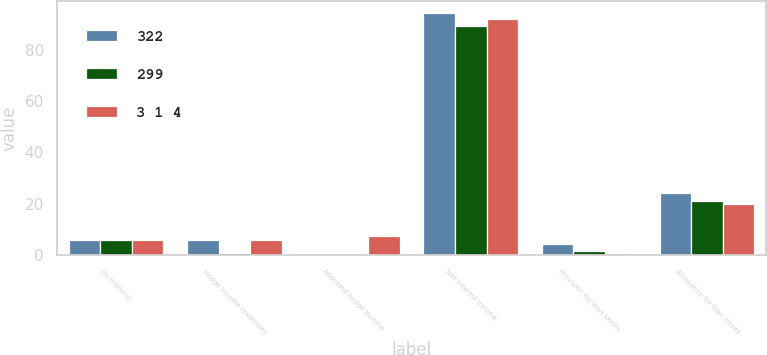<chart> <loc_0><loc_0><loc_500><loc_500><stacked_bar_chart><ecel><fcel>(In millions)<fcel>Hedge income (expense)<fcel>Allocated hedge income<fcel>Net interest income<fcel>Provision for loan losses<fcel>Allowance for loan losses<nl><fcel>322<fcel>6<fcel>6<fcel>0.3<fcel>94.2<fcel>4.2<fcel>24<nl><fcel>299<fcel>6<fcel>0.9<fcel>0.1<fcel>89.1<fcel>1.6<fcel>21<nl><fcel>3 1 4<fcel>6<fcel>5.8<fcel>7.3<fcel>92.1<fcel>0.7<fcel>20<nl></chart> 